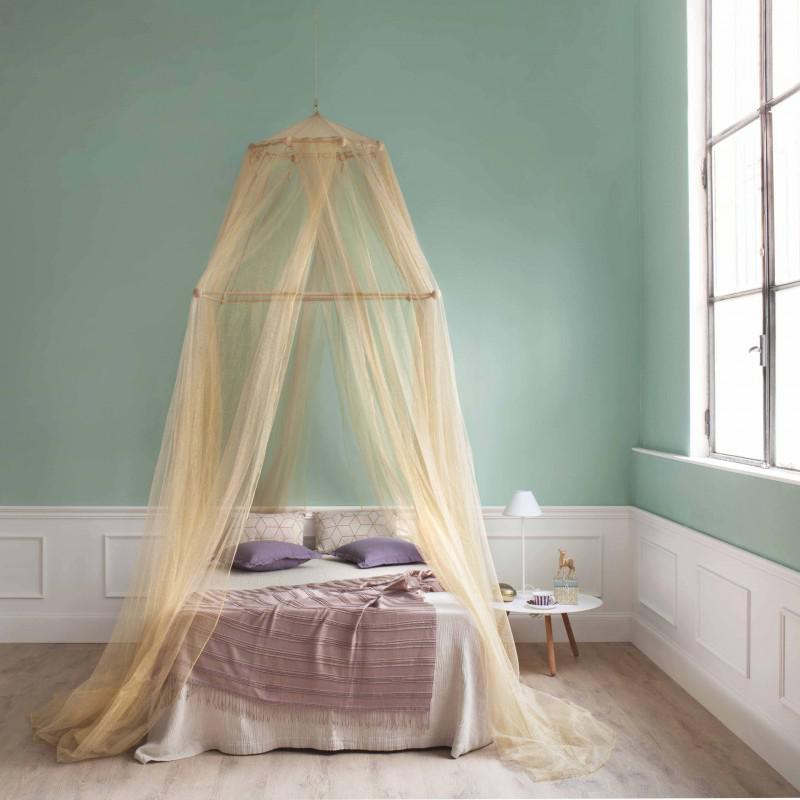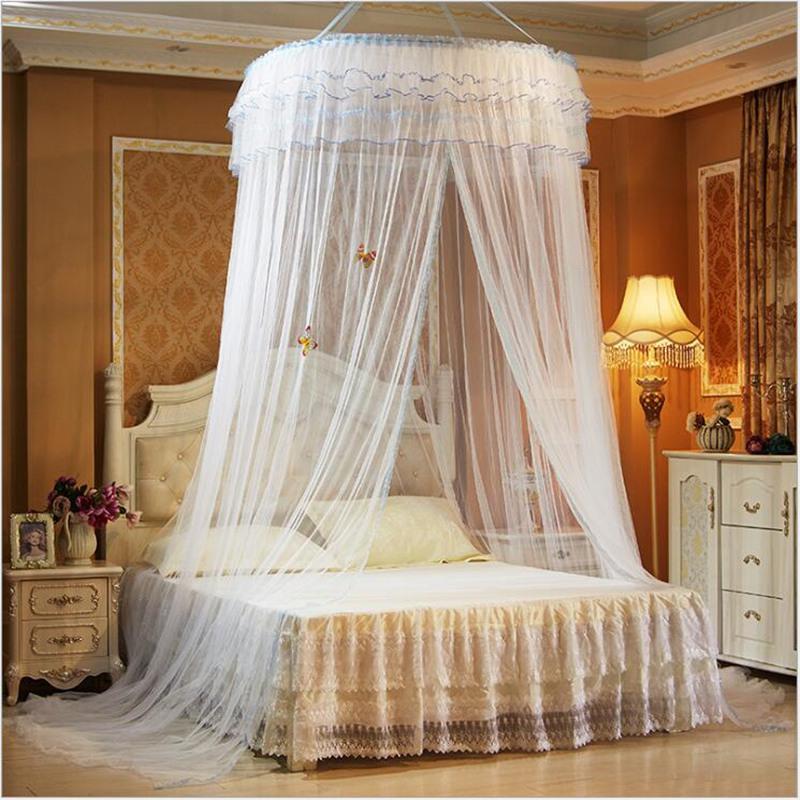The first image is the image on the left, the second image is the image on the right. Assess this claim about the two images: "There is a baby visible in one image.". Correct or not? Answer yes or no. No. The first image is the image on the left, the second image is the image on the right. Analyze the images presented: Is the assertion "The left and right image contains a total of two open canopies." valid? Answer yes or no. Yes. 